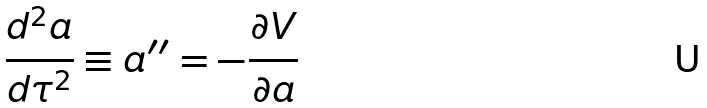Convert formula to latex. <formula><loc_0><loc_0><loc_500><loc_500>\frac { d ^ { 2 } a } { d \tau ^ { 2 } } \equiv a ^ { \prime \prime } = - \frac { \partial V } { \partial a }</formula> 